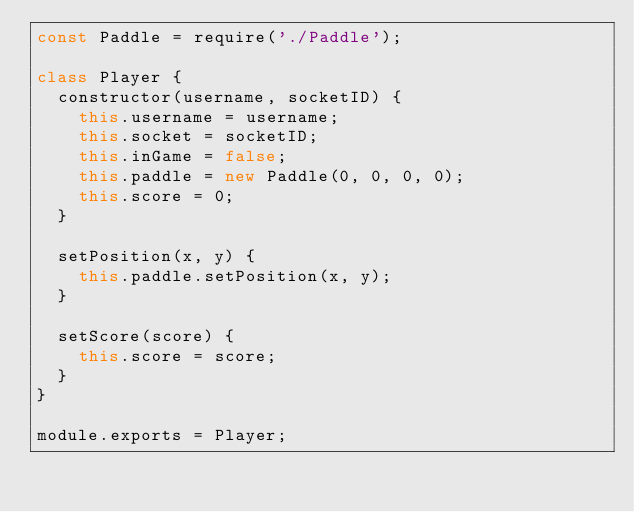<code> <loc_0><loc_0><loc_500><loc_500><_JavaScript_>const Paddle = require('./Paddle');

class Player {
  constructor(username, socketID) {
    this.username = username;
    this.socket = socketID;
    this.inGame = false;
    this.paddle = new Paddle(0, 0, 0, 0);
    this.score = 0;
  }

  setPosition(x, y) {
    this.paddle.setPosition(x, y);
  }

  setScore(score) {
    this.score = score;
  }
}

module.exports = Player;

</code> 